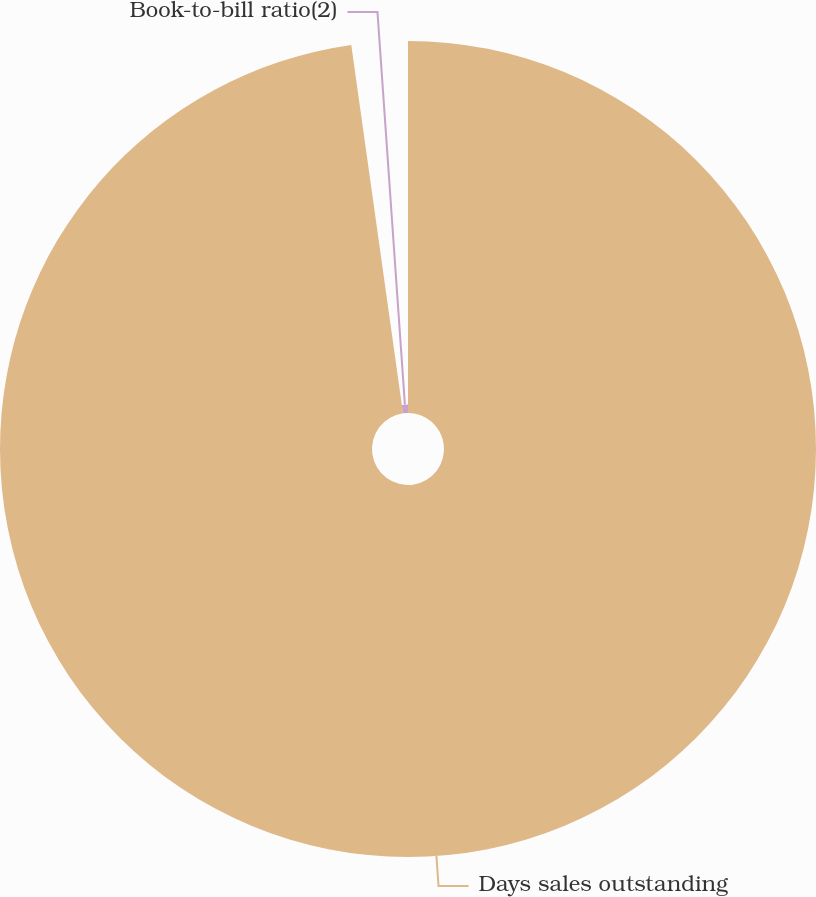<chart> <loc_0><loc_0><loc_500><loc_500><pie_chart><fcel>Days sales outstanding<fcel>Book-to-bill ratio(2)<nl><fcel>97.78%<fcel>2.22%<nl></chart> 